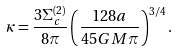<formula> <loc_0><loc_0><loc_500><loc_500>\kappa = \frac { 3 \Sigma ^ { ( 2 ) } _ { c } } { 8 \pi } \left ( \frac { 1 2 8 a } { 4 5 G M \pi } \right ) ^ { 3 / 4 } .</formula> 